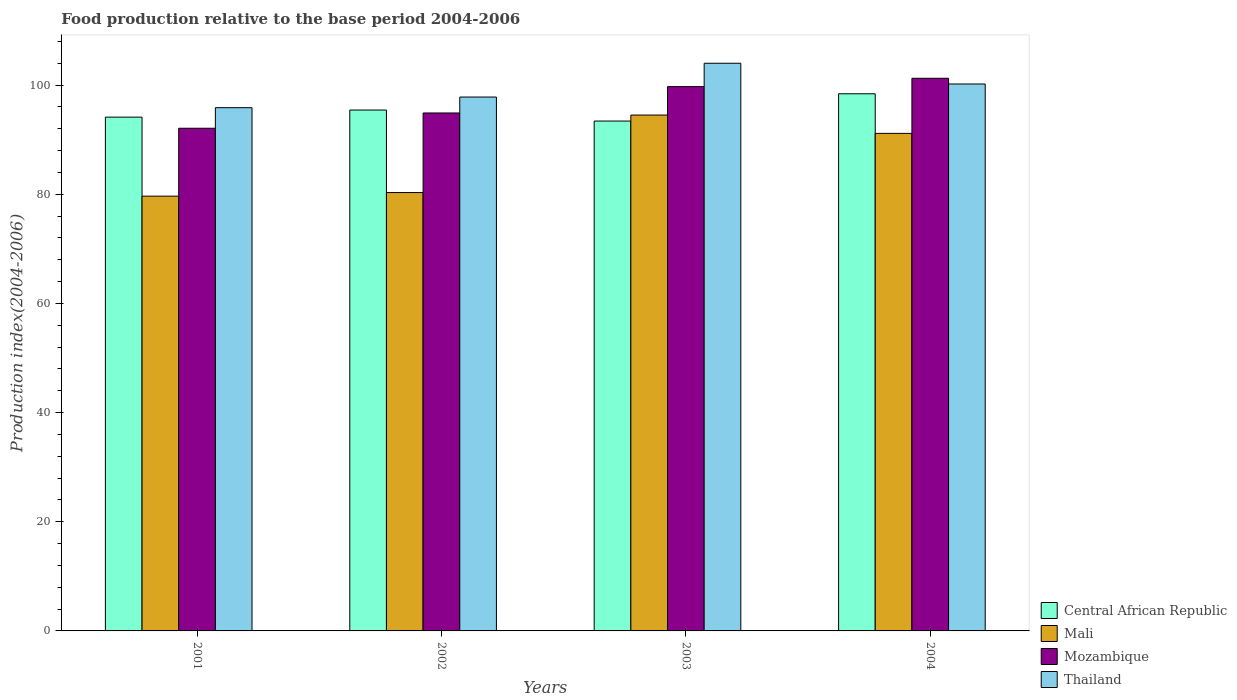How many different coloured bars are there?
Provide a short and direct response. 4. How many groups of bars are there?
Your response must be concise. 4. How many bars are there on the 2nd tick from the left?
Your response must be concise. 4. How many bars are there on the 1st tick from the right?
Provide a succinct answer. 4. What is the label of the 4th group of bars from the left?
Offer a very short reply. 2004. In how many cases, is the number of bars for a given year not equal to the number of legend labels?
Your response must be concise. 0. What is the food production index in Central African Republic in 2001?
Your answer should be compact. 94.14. Across all years, what is the maximum food production index in Central African Republic?
Your answer should be compact. 98.42. Across all years, what is the minimum food production index in Central African Republic?
Offer a very short reply. 93.42. In which year was the food production index in Thailand maximum?
Make the answer very short. 2003. In which year was the food production index in Thailand minimum?
Give a very brief answer. 2001. What is the total food production index in Mali in the graph?
Provide a succinct answer. 345.66. What is the difference between the food production index in Mali in 2001 and that in 2002?
Your answer should be very brief. -0.66. What is the difference between the food production index in Thailand in 2001 and the food production index in Mali in 2002?
Provide a succinct answer. 15.55. What is the average food production index in Central African Republic per year?
Your answer should be compact. 95.36. In the year 2004, what is the difference between the food production index in Mali and food production index in Thailand?
Provide a succinct answer. -9.05. In how many years, is the food production index in Mozambique greater than 40?
Your response must be concise. 4. What is the ratio of the food production index in Thailand in 2001 to that in 2003?
Give a very brief answer. 0.92. Is the food production index in Mali in 2002 less than that in 2003?
Keep it short and to the point. Yes. Is the difference between the food production index in Mali in 2002 and 2003 greater than the difference between the food production index in Thailand in 2002 and 2003?
Ensure brevity in your answer.  No. What is the difference between the highest and the second highest food production index in Central African Republic?
Your answer should be very brief. 2.98. What is the difference between the highest and the lowest food production index in Mozambique?
Provide a succinct answer. 9.16. In how many years, is the food production index in Thailand greater than the average food production index in Thailand taken over all years?
Make the answer very short. 2. What does the 1st bar from the left in 2002 represents?
Your answer should be compact. Central African Republic. What does the 2nd bar from the right in 2004 represents?
Keep it short and to the point. Mozambique. Is it the case that in every year, the sum of the food production index in Central African Republic and food production index in Mali is greater than the food production index in Mozambique?
Your response must be concise. Yes. How many bars are there?
Ensure brevity in your answer.  16. Are all the bars in the graph horizontal?
Keep it short and to the point. No. How many years are there in the graph?
Your answer should be very brief. 4. Does the graph contain any zero values?
Your answer should be very brief. No. Does the graph contain grids?
Give a very brief answer. No. How many legend labels are there?
Provide a short and direct response. 4. What is the title of the graph?
Your answer should be very brief. Food production relative to the base period 2004-2006. What is the label or title of the Y-axis?
Provide a short and direct response. Production index(2004-2006). What is the Production index(2004-2006) of Central African Republic in 2001?
Make the answer very short. 94.14. What is the Production index(2004-2006) of Mali in 2001?
Your answer should be very brief. 79.66. What is the Production index(2004-2006) of Mozambique in 2001?
Ensure brevity in your answer.  92.1. What is the Production index(2004-2006) of Thailand in 2001?
Your answer should be compact. 95.87. What is the Production index(2004-2006) in Central African Republic in 2002?
Offer a very short reply. 95.44. What is the Production index(2004-2006) in Mali in 2002?
Provide a short and direct response. 80.32. What is the Production index(2004-2006) in Mozambique in 2002?
Provide a succinct answer. 94.9. What is the Production index(2004-2006) of Thailand in 2002?
Your response must be concise. 97.82. What is the Production index(2004-2006) of Central African Republic in 2003?
Keep it short and to the point. 93.42. What is the Production index(2004-2006) of Mali in 2003?
Ensure brevity in your answer.  94.52. What is the Production index(2004-2006) in Mozambique in 2003?
Your response must be concise. 99.73. What is the Production index(2004-2006) of Thailand in 2003?
Give a very brief answer. 104.01. What is the Production index(2004-2006) in Central African Republic in 2004?
Keep it short and to the point. 98.42. What is the Production index(2004-2006) of Mali in 2004?
Provide a succinct answer. 91.16. What is the Production index(2004-2006) in Mozambique in 2004?
Ensure brevity in your answer.  101.26. What is the Production index(2004-2006) in Thailand in 2004?
Keep it short and to the point. 100.21. Across all years, what is the maximum Production index(2004-2006) of Central African Republic?
Provide a short and direct response. 98.42. Across all years, what is the maximum Production index(2004-2006) of Mali?
Ensure brevity in your answer.  94.52. Across all years, what is the maximum Production index(2004-2006) in Mozambique?
Your response must be concise. 101.26. Across all years, what is the maximum Production index(2004-2006) in Thailand?
Your answer should be very brief. 104.01. Across all years, what is the minimum Production index(2004-2006) of Central African Republic?
Make the answer very short. 93.42. Across all years, what is the minimum Production index(2004-2006) of Mali?
Your response must be concise. 79.66. Across all years, what is the minimum Production index(2004-2006) of Mozambique?
Make the answer very short. 92.1. Across all years, what is the minimum Production index(2004-2006) in Thailand?
Offer a terse response. 95.87. What is the total Production index(2004-2006) of Central African Republic in the graph?
Make the answer very short. 381.42. What is the total Production index(2004-2006) in Mali in the graph?
Your answer should be very brief. 345.66. What is the total Production index(2004-2006) of Mozambique in the graph?
Give a very brief answer. 387.99. What is the total Production index(2004-2006) of Thailand in the graph?
Offer a terse response. 397.91. What is the difference between the Production index(2004-2006) in Central African Republic in 2001 and that in 2002?
Offer a terse response. -1.3. What is the difference between the Production index(2004-2006) in Mali in 2001 and that in 2002?
Your response must be concise. -0.66. What is the difference between the Production index(2004-2006) in Thailand in 2001 and that in 2002?
Ensure brevity in your answer.  -1.95. What is the difference between the Production index(2004-2006) in Central African Republic in 2001 and that in 2003?
Offer a terse response. 0.72. What is the difference between the Production index(2004-2006) of Mali in 2001 and that in 2003?
Make the answer very short. -14.86. What is the difference between the Production index(2004-2006) in Mozambique in 2001 and that in 2003?
Offer a very short reply. -7.63. What is the difference between the Production index(2004-2006) of Thailand in 2001 and that in 2003?
Provide a succinct answer. -8.14. What is the difference between the Production index(2004-2006) of Central African Republic in 2001 and that in 2004?
Make the answer very short. -4.28. What is the difference between the Production index(2004-2006) in Mozambique in 2001 and that in 2004?
Ensure brevity in your answer.  -9.16. What is the difference between the Production index(2004-2006) of Thailand in 2001 and that in 2004?
Provide a short and direct response. -4.34. What is the difference between the Production index(2004-2006) in Central African Republic in 2002 and that in 2003?
Your response must be concise. 2.02. What is the difference between the Production index(2004-2006) in Mozambique in 2002 and that in 2003?
Give a very brief answer. -4.83. What is the difference between the Production index(2004-2006) in Thailand in 2002 and that in 2003?
Your response must be concise. -6.19. What is the difference between the Production index(2004-2006) of Central African Republic in 2002 and that in 2004?
Make the answer very short. -2.98. What is the difference between the Production index(2004-2006) of Mali in 2002 and that in 2004?
Give a very brief answer. -10.84. What is the difference between the Production index(2004-2006) of Mozambique in 2002 and that in 2004?
Make the answer very short. -6.36. What is the difference between the Production index(2004-2006) of Thailand in 2002 and that in 2004?
Offer a terse response. -2.39. What is the difference between the Production index(2004-2006) in Central African Republic in 2003 and that in 2004?
Provide a short and direct response. -5. What is the difference between the Production index(2004-2006) in Mali in 2003 and that in 2004?
Provide a short and direct response. 3.36. What is the difference between the Production index(2004-2006) in Mozambique in 2003 and that in 2004?
Keep it short and to the point. -1.53. What is the difference between the Production index(2004-2006) in Central African Republic in 2001 and the Production index(2004-2006) in Mali in 2002?
Offer a very short reply. 13.82. What is the difference between the Production index(2004-2006) in Central African Republic in 2001 and the Production index(2004-2006) in Mozambique in 2002?
Keep it short and to the point. -0.76. What is the difference between the Production index(2004-2006) in Central African Republic in 2001 and the Production index(2004-2006) in Thailand in 2002?
Provide a short and direct response. -3.68. What is the difference between the Production index(2004-2006) in Mali in 2001 and the Production index(2004-2006) in Mozambique in 2002?
Make the answer very short. -15.24. What is the difference between the Production index(2004-2006) of Mali in 2001 and the Production index(2004-2006) of Thailand in 2002?
Make the answer very short. -18.16. What is the difference between the Production index(2004-2006) of Mozambique in 2001 and the Production index(2004-2006) of Thailand in 2002?
Keep it short and to the point. -5.72. What is the difference between the Production index(2004-2006) in Central African Republic in 2001 and the Production index(2004-2006) in Mali in 2003?
Offer a terse response. -0.38. What is the difference between the Production index(2004-2006) of Central African Republic in 2001 and the Production index(2004-2006) of Mozambique in 2003?
Provide a succinct answer. -5.59. What is the difference between the Production index(2004-2006) in Central African Republic in 2001 and the Production index(2004-2006) in Thailand in 2003?
Your answer should be compact. -9.87. What is the difference between the Production index(2004-2006) of Mali in 2001 and the Production index(2004-2006) of Mozambique in 2003?
Provide a succinct answer. -20.07. What is the difference between the Production index(2004-2006) of Mali in 2001 and the Production index(2004-2006) of Thailand in 2003?
Your answer should be very brief. -24.35. What is the difference between the Production index(2004-2006) in Mozambique in 2001 and the Production index(2004-2006) in Thailand in 2003?
Your response must be concise. -11.91. What is the difference between the Production index(2004-2006) of Central African Republic in 2001 and the Production index(2004-2006) of Mali in 2004?
Your answer should be very brief. 2.98. What is the difference between the Production index(2004-2006) in Central African Republic in 2001 and the Production index(2004-2006) in Mozambique in 2004?
Your response must be concise. -7.12. What is the difference between the Production index(2004-2006) in Central African Republic in 2001 and the Production index(2004-2006) in Thailand in 2004?
Provide a short and direct response. -6.07. What is the difference between the Production index(2004-2006) in Mali in 2001 and the Production index(2004-2006) in Mozambique in 2004?
Give a very brief answer. -21.6. What is the difference between the Production index(2004-2006) of Mali in 2001 and the Production index(2004-2006) of Thailand in 2004?
Ensure brevity in your answer.  -20.55. What is the difference between the Production index(2004-2006) of Mozambique in 2001 and the Production index(2004-2006) of Thailand in 2004?
Give a very brief answer. -8.11. What is the difference between the Production index(2004-2006) in Central African Republic in 2002 and the Production index(2004-2006) in Mozambique in 2003?
Provide a succinct answer. -4.29. What is the difference between the Production index(2004-2006) of Central African Republic in 2002 and the Production index(2004-2006) of Thailand in 2003?
Give a very brief answer. -8.57. What is the difference between the Production index(2004-2006) of Mali in 2002 and the Production index(2004-2006) of Mozambique in 2003?
Offer a very short reply. -19.41. What is the difference between the Production index(2004-2006) of Mali in 2002 and the Production index(2004-2006) of Thailand in 2003?
Provide a short and direct response. -23.69. What is the difference between the Production index(2004-2006) of Mozambique in 2002 and the Production index(2004-2006) of Thailand in 2003?
Your answer should be very brief. -9.11. What is the difference between the Production index(2004-2006) in Central African Republic in 2002 and the Production index(2004-2006) in Mali in 2004?
Ensure brevity in your answer.  4.28. What is the difference between the Production index(2004-2006) of Central African Republic in 2002 and the Production index(2004-2006) of Mozambique in 2004?
Your answer should be very brief. -5.82. What is the difference between the Production index(2004-2006) in Central African Republic in 2002 and the Production index(2004-2006) in Thailand in 2004?
Make the answer very short. -4.77. What is the difference between the Production index(2004-2006) in Mali in 2002 and the Production index(2004-2006) in Mozambique in 2004?
Provide a succinct answer. -20.94. What is the difference between the Production index(2004-2006) of Mali in 2002 and the Production index(2004-2006) of Thailand in 2004?
Your answer should be compact. -19.89. What is the difference between the Production index(2004-2006) in Mozambique in 2002 and the Production index(2004-2006) in Thailand in 2004?
Your answer should be very brief. -5.31. What is the difference between the Production index(2004-2006) in Central African Republic in 2003 and the Production index(2004-2006) in Mali in 2004?
Provide a short and direct response. 2.26. What is the difference between the Production index(2004-2006) of Central African Republic in 2003 and the Production index(2004-2006) of Mozambique in 2004?
Provide a succinct answer. -7.84. What is the difference between the Production index(2004-2006) of Central African Republic in 2003 and the Production index(2004-2006) of Thailand in 2004?
Give a very brief answer. -6.79. What is the difference between the Production index(2004-2006) in Mali in 2003 and the Production index(2004-2006) in Mozambique in 2004?
Give a very brief answer. -6.74. What is the difference between the Production index(2004-2006) in Mali in 2003 and the Production index(2004-2006) in Thailand in 2004?
Provide a short and direct response. -5.69. What is the difference between the Production index(2004-2006) in Mozambique in 2003 and the Production index(2004-2006) in Thailand in 2004?
Keep it short and to the point. -0.48. What is the average Production index(2004-2006) in Central African Republic per year?
Keep it short and to the point. 95.36. What is the average Production index(2004-2006) in Mali per year?
Your response must be concise. 86.42. What is the average Production index(2004-2006) in Mozambique per year?
Provide a succinct answer. 97. What is the average Production index(2004-2006) in Thailand per year?
Keep it short and to the point. 99.48. In the year 2001, what is the difference between the Production index(2004-2006) of Central African Republic and Production index(2004-2006) of Mali?
Make the answer very short. 14.48. In the year 2001, what is the difference between the Production index(2004-2006) of Central African Republic and Production index(2004-2006) of Mozambique?
Give a very brief answer. 2.04. In the year 2001, what is the difference between the Production index(2004-2006) in Central African Republic and Production index(2004-2006) in Thailand?
Keep it short and to the point. -1.73. In the year 2001, what is the difference between the Production index(2004-2006) of Mali and Production index(2004-2006) of Mozambique?
Offer a very short reply. -12.44. In the year 2001, what is the difference between the Production index(2004-2006) of Mali and Production index(2004-2006) of Thailand?
Offer a terse response. -16.21. In the year 2001, what is the difference between the Production index(2004-2006) of Mozambique and Production index(2004-2006) of Thailand?
Ensure brevity in your answer.  -3.77. In the year 2002, what is the difference between the Production index(2004-2006) in Central African Republic and Production index(2004-2006) in Mali?
Offer a very short reply. 15.12. In the year 2002, what is the difference between the Production index(2004-2006) of Central African Republic and Production index(2004-2006) of Mozambique?
Your answer should be compact. 0.54. In the year 2002, what is the difference between the Production index(2004-2006) of Central African Republic and Production index(2004-2006) of Thailand?
Ensure brevity in your answer.  -2.38. In the year 2002, what is the difference between the Production index(2004-2006) in Mali and Production index(2004-2006) in Mozambique?
Offer a terse response. -14.58. In the year 2002, what is the difference between the Production index(2004-2006) in Mali and Production index(2004-2006) in Thailand?
Give a very brief answer. -17.5. In the year 2002, what is the difference between the Production index(2004-2006) of Mozambique and Production index(2004-2006) of Thailand?
Keep it short and to the point. -2.92. In the year 2003, what is the difference between the Production index(2004-2006) in Central African Republic and Production index(2004-2006) in Mozambique?
Ensure brevity in your answer.  -6.31. In the year 2003, what is the difference between the Production index(2004-2006) in Central African Republic and Production index(2004-2006) in Thailand?
Provide a succinct answer. -10.59. In the year 2003, what is the difference between the Production index(2004-2006) in Mali and Production index(2004-2006) in Mozambique?
Give a very brief answer. -5.21. In the year 2003, what is the difference between the Production index(2004-2006) in Mali and Production index(2004-2006) in Thailand?
Keep it short and to the point. -9.49. In the year 2003, what is the difference between the Production index(2004-2006) in Mozambique and Production index(2004-2006) in Thailand?
Offer a terse response. -4.28. In the year 2004, what is the difference between the Production index(2004-2006) of Central African Republic and Production index(2004-2006) of Mali?
Make the answer very short. 7.26. In the year 2004, what is the difference between the Production index(2004-2006) of Central African Republic and Production index(2004-2006) of Mozambique?
Provide a short and direct response. -2.84. In the year 2004, what is the difference between the Production index(2004-2006) in Central African Republic and Production index(2004-2006) in Thailand?
Provide a short and direct response. -1.79. In the year 2004, what is the difference between the Production index(2004-2006) of Mali and Production index(2004-2006) of Thailand?
Offer a terse response. -9.05. In the year 2004, what is the difference between the Production index(2004-2006) of Mozambique and Production index(2004-2006) of Thailand?
Offer a very short reply. 1.05. What is the ratio of the Production index(2004-2006) of Central African Republic in 2001 to that in 2002?
Offer a terse response. 0.99. What is the ratio of the Production index(2004-2006) of Mozambique in 2001 to that in 2002?
Your response must be concise. 0.97. What is the ratio of the Production index(2004-2006) of Thailand in 2001 to that in 2002?
Your answer should be very brief. 0.98. What is the ratio of the Production index(2004-2006) of Central African Republic in 2001 to that in 2003?
Ensure brevity in your answer.  1.01. What is the ratio of the Production index(2004-2006) of Mali in 2001 to that in 2003?
Provide a succinct answer. 0.84. What is the ratio of the Production index(2004-2006) of Mozambique in 2001 to that in 2003?
Offer a very short reply. 0.92. What is the ratio of the Production index(2004-2006) in Thailand in 2001 to that in 2003?
Provide a short and direct response. 0.92. What is the ratio of the Production index(2004-2006) in Central African Republic in 2001 to that in 2004?
Keep it short and to the point. 0.96. What is the ratio of the Production index(2004-2006) of Mali in 2001 to that in 2004?
Provide a succinct answer. 0.87. What is the ratio of the Production index(2004-2006) of Mozambique in 2001 to that in 2004?
Ensure brevity in your answer.  0.91. What is the ratio of the Production index(2004-2006) of Thailand in 2001 to that in 2004?
Provide a short and direct response. 0.96. What is the ratio of the Production index(2004-2006) of Central African Republic in 2002 to that in 2003?
Offer a very short reply. 1.02. What is the ratio of the Production index(2004-2006) in Mali in 2002 to that in 2003?
Keep it short and to the point. 0.85. What is the ratio of the Production index(2004-2006) in Mozambique in 2002 to that in 2003?
Your response must be concise. 0.95. What is the ratio of the Production index(2004-2006) of Thailand in 2002 to that in 2003?
Provide a short and direct response. 0.94. What is the ratio of the Production index(2004-2006) in Central African Republic in 2002 to that in 2004?
Your answer should be very brief. 0.97. What is the ratio of the Production index(2004-2006) in Mali in 2002 to that in 2004?
Your answer should be very brief. 0.88. What is the ratio of the Production index(2004-2006) in Mozambique in 2002 to that in 2004?
Your response must be concise. 0.94. What is the ratio of the Production index(2004-2006) of Thailand in 2002 to that in 2004?
Offer a very short reply. 0.98. What is the ratio of the Production index(2004-2006) in Central African Republic in 2003 to that in 2004?
Your answer should be very brief. 0.95. What is the ratio of the Production index(2004-2006) of Mali in 2003 to that in 2004?
Provide a succinct answer. 1.04. What is the ratio of the Production index(2004-2006) of Mozambique in 2003 to that in 2004?
Your response must be concise. 0.98. What is the ratio of the Production index(2004-2006) in Thailand in 2003 to that in 2004?
Make the answer very short. 1.04. What is the difference between the highest and the second highest Production index(2004-2006) of Central African Republic?
Keep it short and to the point. 2.98. What is the difference between the highest and the second highest Production index(2004-2006) in Mali?
Provide a short and direct response. 3.36. What is the difference between the highest and the second highest Production index(2004-2006) in Mozambique?
Ensure brevity in your answer.  1.53. What is the difference between the highest and the lowest Production index(2004-2006) in Central African Republic?
Keep it short and to the point. 5. What is the difference between the highest and the lowest Production index(2004-2006) in Mali?
Offer a very short reply. 14.86. What is the difference between the highest and the lowest Production index(2004-2006) in Mozambique?
Give a very brief answer. 9.16. What is the difference between the highest and the lowest Production index(2004-2006) in Thailand?
Your answer should be compact. 8.14. 